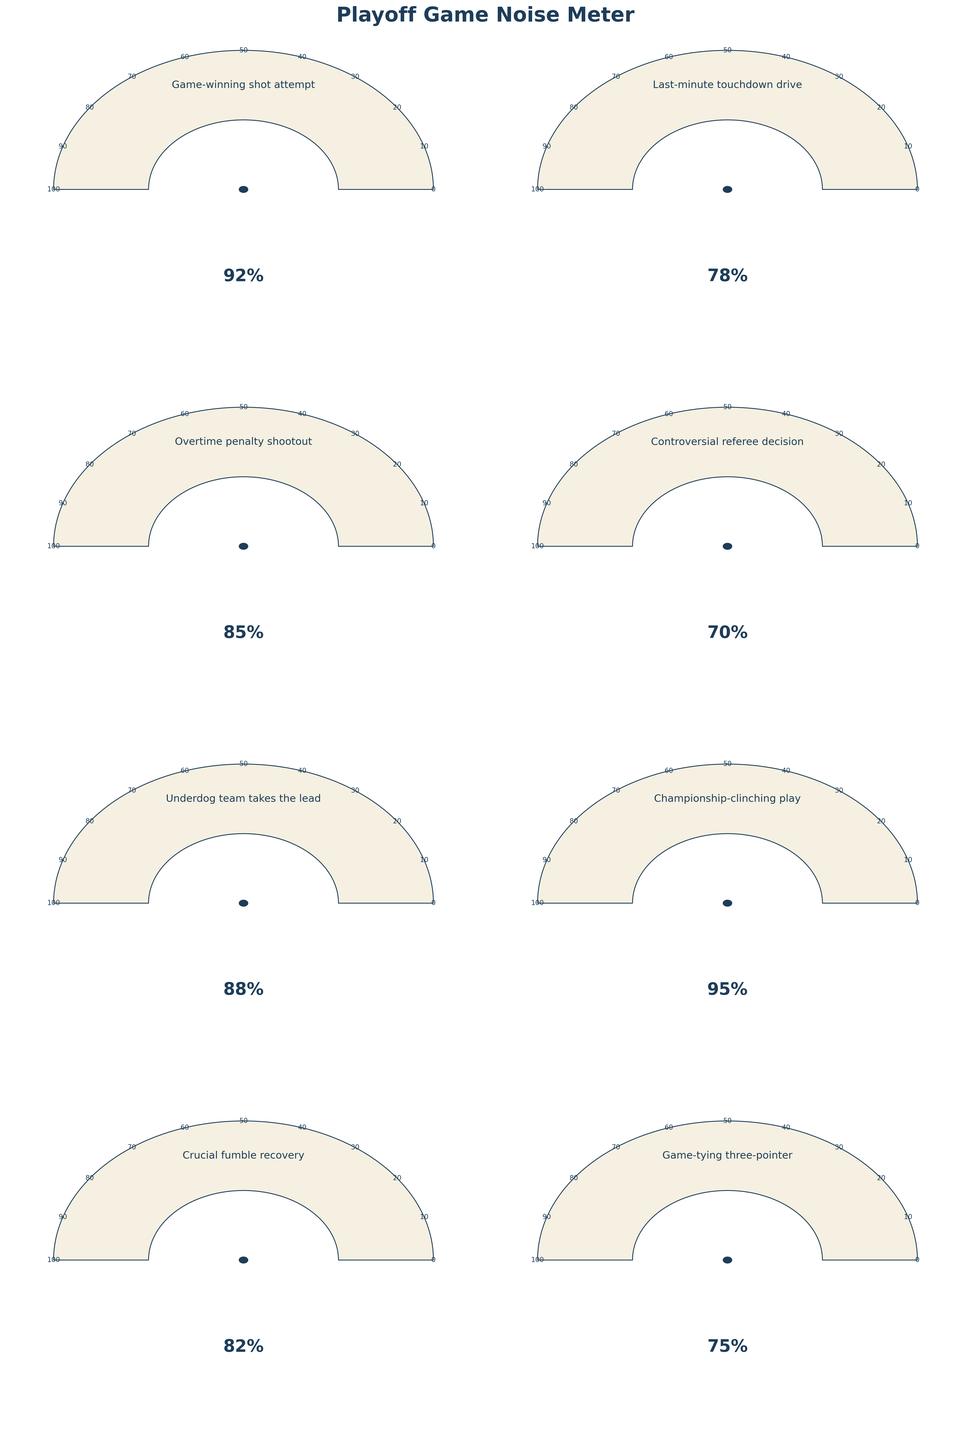What is the title of the figure? The title of the figure is placed at the top of the plot and clearly labels what the figure represents.
Answer: Playoff Game Noise Meter How many moments are represented in the figure? By counting the individual gauge charts, we can determine how many moments are shown.
Answer: 8 What's the average noise level for all the crucial moments displayed? Add up the noise levels for all 8 moments (92 + 78 + 85 + 70 + 88 + 95 + 82 + 75) and then divide by the total number of moments (8) to find the average. The sum is 665, so the average is 665/8.
Answer: 83.125 What's the difference in noise level between the "Last-minute touchdown drive" and the "Overtime penalty shootout"? Subtract the noise level of the "Last-minute touchdown drive" (78%) from the "Overtime penalty shootout" (85%).
Answer: 7% Which moment had the highest noise level? By checking each gauge chart's highest value, we find the "Championship-clinching play" has the highest value of 95%.
Answer: Championship-clinching play Which moment had the lowest noise level? By checking each gauge chart's lowest value, we find the "Controversial referee decision" has the lowest value of 70%.
Answer: Controversial referee decision Which moments have noise levels greater than 90%? By identifying the gauge charts with values above 90%, we find "Championship-clinching play" (95%) and "Game-winning shot attempt" (92%).
Answer: Game-winning shot attempt, Championship-clinching play How many moments had noise levels in the yellow zone (75-85%)? We can identify the gauge charts with values within the range of 75 to 85%. The moments are "Last-minute touchdown drive" (78%), "Overtime penalty shootout" (85%), and "Crucial fumble recovery" (82%).
Answer: 3 Which moment saw the underdog team take the lead based on the noise level? By identifying the label descriptions on the gauges, we locate "Underdog team takes the lead" with a noise level of 88%.
Answer: Underdog team takes the lead What colors are used to represent different noise levels? By examining the gauge chart, we see different colors: red for values below 75, yellow for values between 75 and 85, and turquoise for values greater than 85.
Answer: Red, Yellow, Turquoise 